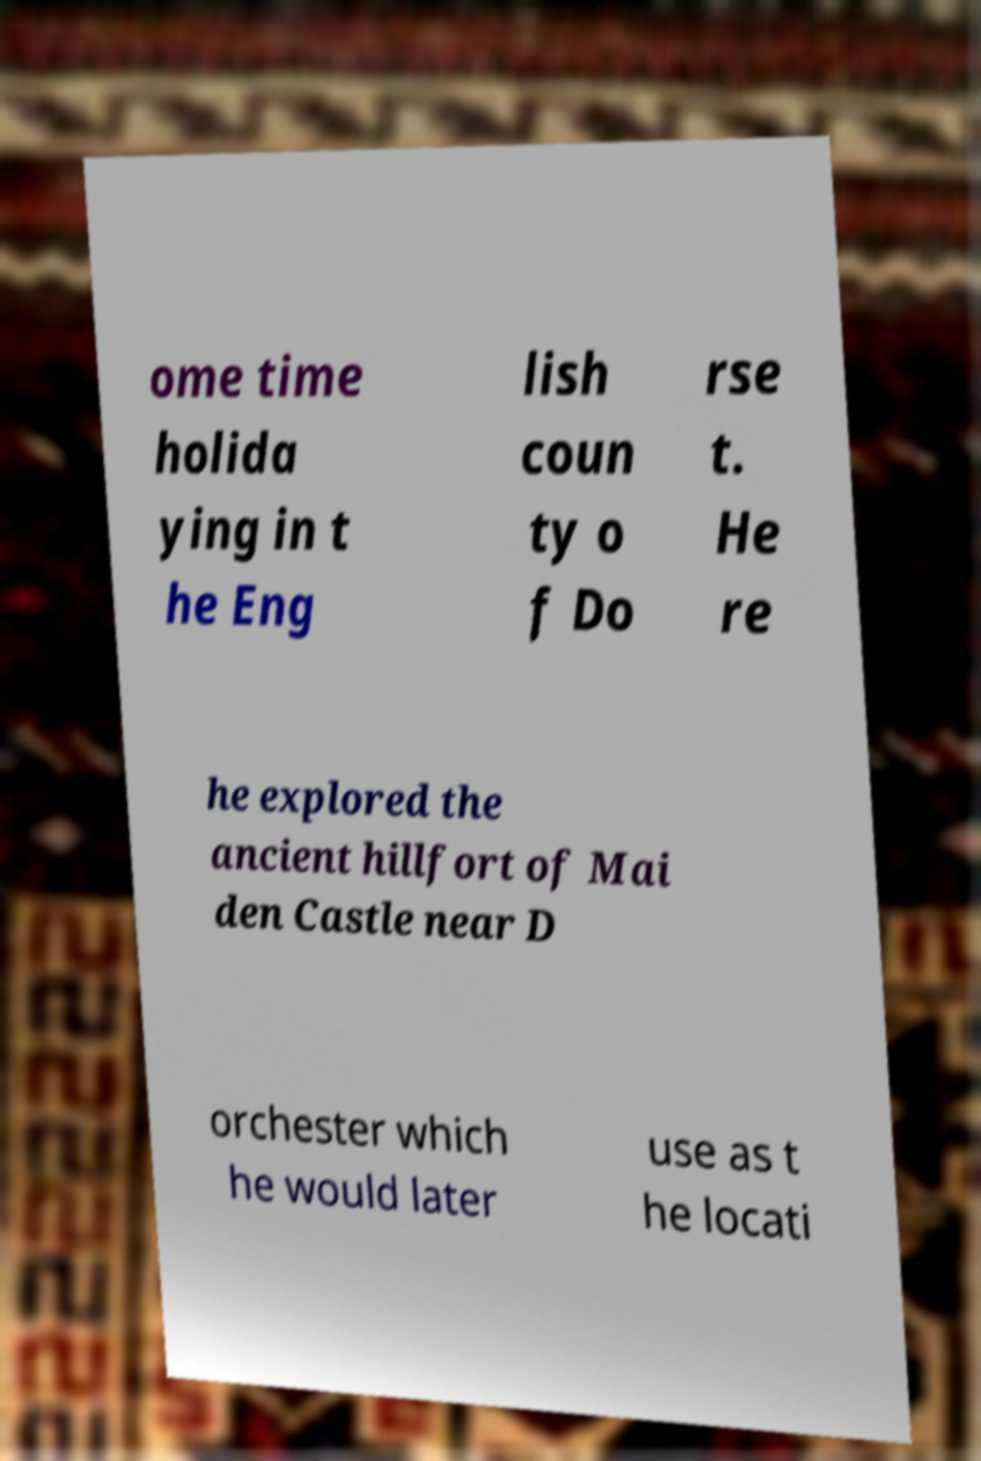Could you assist in decoding the text presented in this image and type it out clearly? ome time holida ying in t he Eng lish coun ty o f Do rse t. He re he explored the ancient hillfort of Mai den Castle near D orchester which he would later use as t he locati 